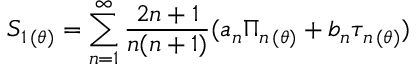Convert formula to latex. <formula><loc_0><loc_0><loc_500><loc_500>S _ { 1 \, ( \theta ) } = \sum _ { n = 1 } ^ { \infty } \frac { 2 n + 1 } { n ( n + 1 ) } ( a _ { n } \Pi _ { n \, ( \theta ) } + b _ { n } \tau _ { n \, ( \theta ) } )</formula> 